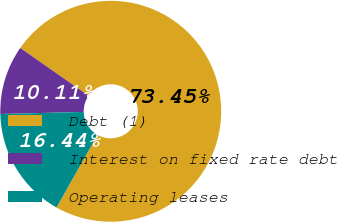Convert chart. <chart><loc_0><loc_0><loc_500><loc_500><pie_chart><fcel>Debt (1)<fcel>Interest on fixed rate debt<fcel>Operating leases<nl><fcel>73.44%<fcel>10.11%<fcel>16.44%<nl></chart> 